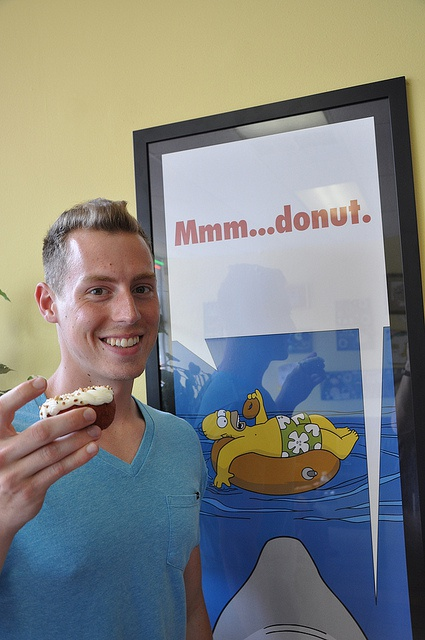Describe the objects in this image and their specific colors. I can see people in tan, blue, gray, and teal tones and donut in tan, lightgray, black, darkgray, and maroon tones in this image. 